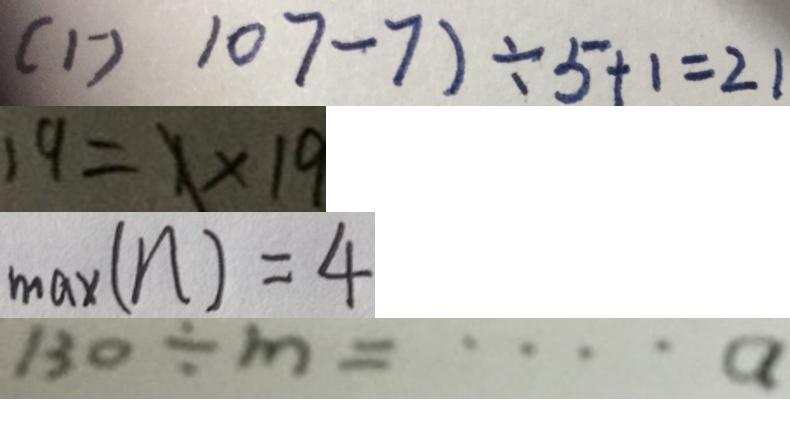<formula> <loc_0><loc_0><loc_500><loc_500>( 1 ^ { - } ) 1 0 7 - 7 ) \div 5 + 1 = 2 1 
 1 9 = 1 \times 1 9 
 \max ( n ) = 4 
 1 3 0 \div m = \cdots a</formula> 